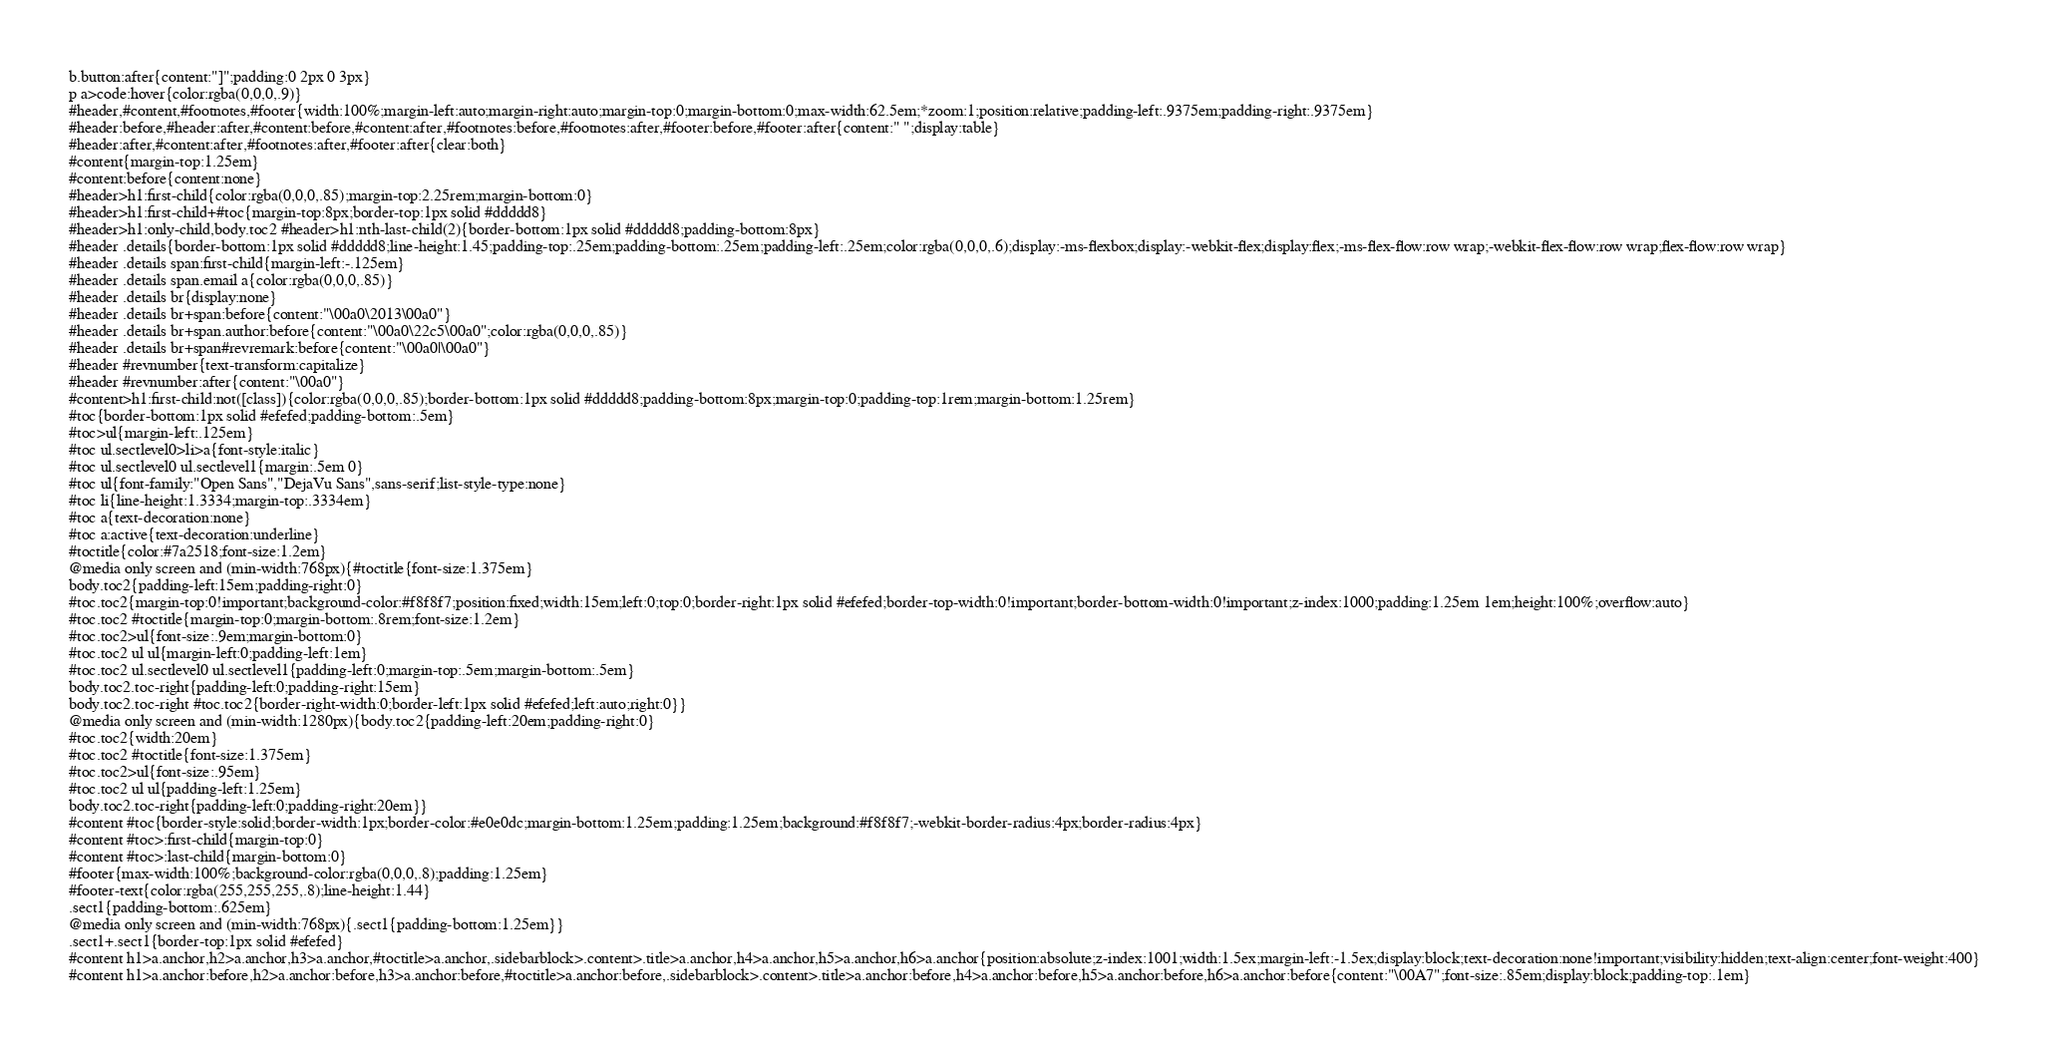<code> <loc_0><loc_0><loc_500><loc_500><_HTML_>b.button:after{content:"]";padding:0 2px 0 3px}
p a>code:hover{color:rgba(0,0,0,.9)}
#header,#content,#footnotes,#footer{width:100%;margin-left:auto;margin-right:auto;margin-top:0;margin-bottom:0;max-width:62.5em;*zoom:1;position:relative;padding-left:.9375em;padding-right:.9375em}
#header:before,#header:after,#content:before,#content:after,#footnotes:before,#footnotes:after,#footer:before,#footer:after{content:" ";display:table}
#header:after,#content:after,#footnotes:after,#footer:after{clear:both}
#content{margin-top:1.25em}
#content:before{content:none}
#header>h1:first-child{color:rgba(0,0,0,.85);margin-top:2.25rem;margin-bottom:0}
#header>h1:first-child+#toc{margin-top:8px;border-top:1px solid #ddddd8}
#header>h1:only-child,body.toc2 #header>h1:nth-last-child(2){border-bottom:1px solid #ddddd8;padding-bottom:8px}
#header .details{border-bottom:1px solid #ddddd8;line-height:1.45;padding-top:.25em;padding-bottom:.25em;padding-left:.25em;color:rgba(0,0,0,.6);display:-ms-flexbox;display:-webkit-flex;display:flex;-ms-flex-flow:row wrap;-webkit-flex-flow:row wrap;flex-flow:row wrap}
#header .details span:first-child{margin-left:-.125em}
#header .details span.email a{color:rgba(0,0,0,.85)}
#header .details br{display:none}
#header .details br+span:before{content:"\00a0\2013\00a0"}
#header .details br+span.author:before{content:"\00a0\22c5\00a0";color:rgba(0,0,0,.85)}
#header .details br+span#revremark:before{content:"\00a0|\00a0"}
#header #revnumber{text-transform:capitalize}
#header #revnumber:after{content:"\00a0"}
#content>h1:first-child:not([class]){color:rgba(0,0,0,.85);border-bottom:1px solid #ddddd8;padding-bottom:8px;margin-top:0;padding-top:1rem;margin-bottom:1.25rem}
#toc{border-bottom:1px solid #efefed;padding-bottom:.5em}
#toc>ul{margin-left:.125em}
#toc ul.sectlevel0>li>a{font-style:italic}
#toc ul.sectlevel0 ul.sectlevel1{margin:.5em 0}
#toc ul{font-family:"Open Sans","DejaVu Sans",sans-serif;list-style-type:none}
#toc li{line-height:1.3334;margin-top:.3334em}
#toc a{text-decoration:none}
#toc a:active{text-decoration:underline}
#toctitle{color:#7a2518;font-size:1.2em}
@media only screen and (min-width:768px){#toctitle{font-size:1.375em}
body.toc2{padding-left:15em;padding-right:0}
#toc.toc2{margin-top:0!important;background-color:#f8f8f7;position:fixed;width:15em;left:0;top:0;border-right:1px solid #efefed;border-top-width:0!important;border-bottom-width:0!important;z-index:1000;padding:1.25em 1em;height:100%;overflow:auto}
#toc.toc2 #toctitle{margin-top:0;margin-bottom:.8rem;font-size:1.2em}
#toc.toc2>ul{font-size:.9em;margin-bottom:0}
#toc.toc2 ul ul{margin-left:0;padding-left:1em}
#toc.toc2 ul.sectlevel0 ul.sectlevel1{padding-left:0;margin-top:.5em;margin-bottom:.5em}
body.toc2.toc-right{padding-left:0;padding-right:15em}
body.toc2.toc-right #toc.toc2{border-right-width:0;border-left:1px solid #efefed;left:auto;right:0}}
@media only screen and (min-width:1280px){body.toc2{padding-left:20em;padding-right:0}
#toc.toc2{width:20em}
#toc.toc2 #toctitle{font-size:1.375em}
#toc.toc2>ul{font-size:.95em}
#toc.toc2 ul ul{padding-left:1.25em}
body.toc2.toc-right{padding-left:0;padding-right:20em}}
#content #toc{border-style:solid;border-width:1px;border-color:#e0e0dc;margin-bottom:1.25em;padding:1.25em;background:#f8f8f7;-webkit-border-radius:4px;border-radius:4px}
#content #toc>:first-child{margin-top:0}
#content #toc>:last-child{margin-bottom:0}
#footer{max-width:100%;background-color:rgba(0,0,0,.8);padding:1.25em}
#footer-text{color:rgba(255,255,255,.8);line-height:1.44}
.sect1{padding-bottom:.625em}
@media only screen and (min-width:768px){.sect1{padding-bottom:1.25em}}
.sect1+.sect1{border-top:1px solid #efefed}
#content h1>a.anchor,h2>a.anchor,h3>a.anchor,#toctitle>a.anchor,.sidebarblock>.content>.title>a.anchor,h4>a.anchor,h5>a.anchor,h6>a.anchor{position:absolute;z-index:1001;width:1.5ex;margin-left:-1.5ex;display:block;text-decoration:none!important;visibility:hidden;text-align:center;font-weight:400}
#content h1>a.anchor:before,h2>a.anchor:before,h3>a.anchor:before,#toctitle>a.anchor:before,.sidebarblock>.content>.title>a.anchor:before,h4>a.anchor:before,h5>a.anchor:before,h6>a.anchor:before{content:"\00A7";font-size:.85em;display:block;padding-top:.1em}</code> 